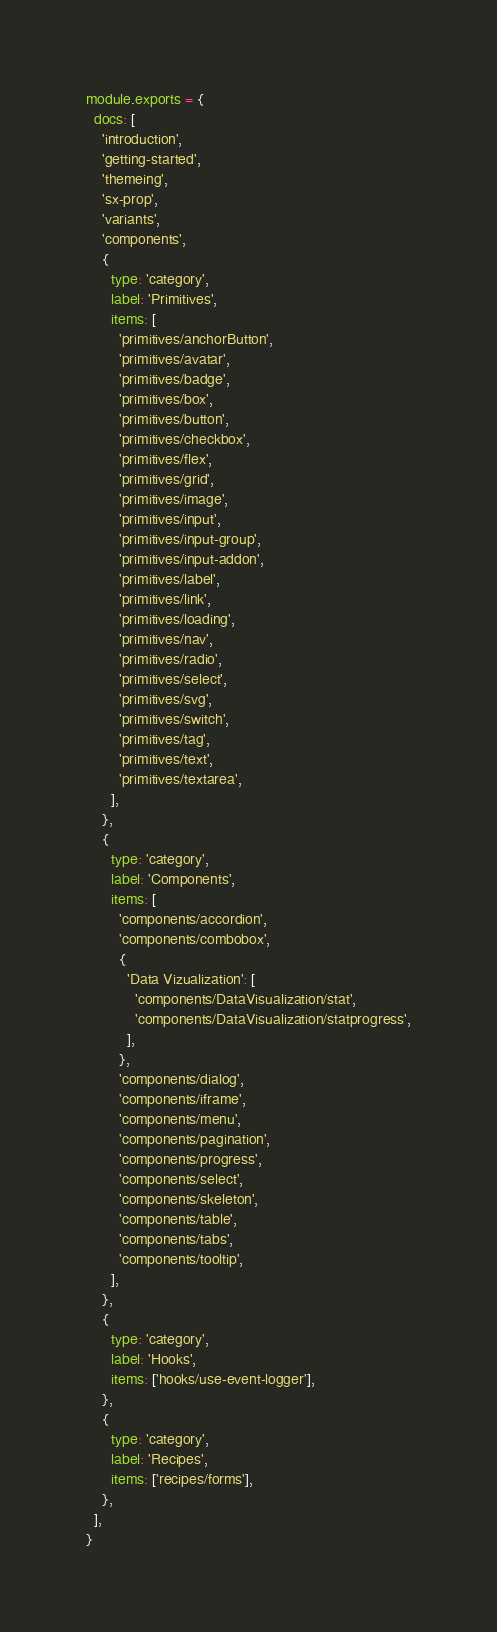<code> <loc_0><loc_0><loc_500><loc_500><_JavaScript_>module.exports = {
  docs: [
    'introduction',
    'getting-started',
    'themeing',
    'sx-prop',
    'variants',
    'components',
    {
      type: 'category',
      label: 'Primitives',
      items: [
        'primitives/anchorButton',
        'primitives/avatar',
        'primitives/badge',
        'primitives/box',
        'primitives/button',
        'primitives/checkbox',
        'primitives/flex',
        'primitives/grid',
        'primitives/image',
        'primitives/input',
        'primitives/input-group',
        'primitives/input-addon',
        'primitives/label',
        'primitives/link',
        'primitives/loading',
        'primitives/nav',
        'primitives/radio',
        'primitives/select',
        'primitives/svg',
        'primitives/switch',
        'primitives/tag',
        'primitives/text',
        'primitives/textarea',
      ],
    },
    {
      type: 'category',
      label: 'Components',
      items: [
        'components/accordion',
        'components/combobox',
        {
          'Data Vizualization': [
            'components/DataVisualization/stat',
            'components/DataVisualization/statprogress',
          ],
        },
        'components/dialog',
        'components/iframe',
        'components/menu',
        'components/pagination',
        'components/progress',
        'components/select',
        'components/skeleton',
        'components/table',
        'components/tabs',
        'components/tooltip',
      ],
    },
    {
      type: 'category',
      label: 'Hooks',
      items: ['hooks/use-event-logger'],
    },
    {
      type: 'category',
      label: 'Recipes',
      items: ['recipes/forms'],
    },
  ],
}
</code> 